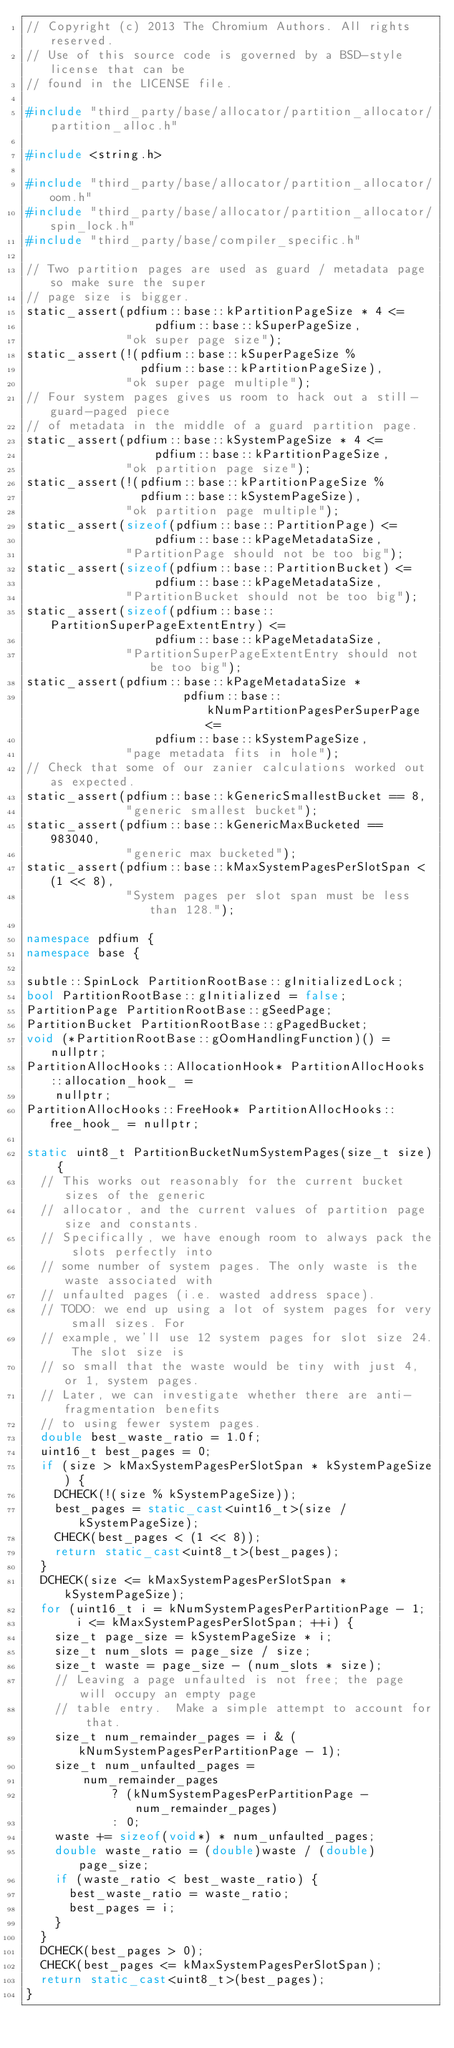<code> <loc_0><loc_0><loc_500><loc_500><_C++_>// Copyright (c) 2013 The Chromium Authors. All rights reserved.
// Use of this source code is governed by a BSD-style license that can be
// found in the LICENSE file.

#include "third_party/base/allocator/partition_allocator/partition_alloc.h"

#include <string.h>

#include "third_party/base/allocator/partition_allocator/oom.h"
#include "third_party/base/allocator/partition_allocator/spin_lock.h"
#include "third_party/base/compiler_specific.h"

// Two partition pages are used as guard / metadata page so make sure the super
// page size is bigger.
static_assert(pdfium::base::kPartitionPageSize * 4 <=
                  pdfium::base::kSuperPageSize,
              "ok super page size");
static_assert(!(pdfium::base::kSuperPageSize %
                pdfium::base::kPartitionPageSize),
              "ok super page multiple");
// Four system pages gives us room to hack out a still-guard-paged piece
// of metadata in the middle of a guard partition page.
static_assert(pdfium::base::kSystemPageSize * 4 <=
                  pdfium::base::kPartitionPageSize,
              "ok partition page size");
static_assert(!(pdfium::base::kPartitionPageSize %
                pdfium::base::kSystemPageSize),
              "ok partition page multiple");
static_assert(sizeof(pdfium::base::PartitionPage) <=
                  pdfium::base::kPageMetadataSize,
              "PartitionPage should not be too big");
static_assert(sizeof(pdfium::base::PartitionBucket) <=
                  pdfium::base::kPageMetadataSize,
              "PartitionBucket should not be too big");
static_assert(sizeof(pdfium::base::PartitionSuperPageExtentEntry) <=
                  pdfium::base::kPageMetadataSize,
              "PartitionSuperPageExtentEntry should not be too big");
static_assert(pdfium::base::kPageMetadataSize *
                      pdfium::base::kNumPartitionPagesPerSuperPage <=
                  pdfium::base::kSystemPageSize,
              "page metadata fits in hole");
// Check that some of our zanier calculations worked out as expected.
static_assert(pdfium::base::kGenericSmallestBucket == 8,
              "generic smallest bucket");
static_assert(pdfium::base::kGenericMaxBucketed == 983040,
              "generic max bucketed");
static_assert(pdfium::base::kMaxSystemPagesPerSlotSpan < (1 << 8),
              "System pages per slot span must be less than 128.");

namespace pdfium {
namespace base {

subtle::SpinLock PartitionRootBase::gInitializedLock;
bool PartitionRootBase::gInitialized = false;
PartitionPage PartitionRootBase::gSeedPage;
PartitionBucket PartitionRootBase::gPagedBucket;
void (*PartitionRootBase::gOomHandlingFunction)() = nullptr;
PartitionAllocHooks::AllocationHook* PartitionAllocHooks::allocation_hook_ =
    nullptr;
PartitionAllocHooks::FreeHook* PartitionAllocHooks::free_hook_ = nullptr;

static uint8_t PartitionBucketNumSystemPages(size_t size) {
  // This works out reasonably for the current bucket sizes of the generic
  // allocator, and the current values of partition page size and constants.
  // Specifically, we have enough room to always pack the slots perfectly into
  // some number of system pages. The only waste is the waste associated with
  // unfaulted pages (i.e. wasted address space).
  // TODO: we end up using a lot of system pages for very small sizes. For
  // example, we'll use 12 system pages for slot size 24. The slot size is
  // so small that the waste would be tiny with just 4, or 1, system pages.
  // Later, we can investigate whether there are anti-fragmentation benefits
  // to using fewer system pages.
  double best_waste_ratio = 1.0f;
  uint16_t best_pages = 0;
  if (size > kMaxSystemPagesPerSlotSpan * kSystemPageSize) {
    DCHECK(!(size % kSystemPageSize));
    best_pages = static_cast<uint16_t>(size / kSystemPageSize);
    CHECK(best_pages < (1 << 8));
    return static_cast<uint8_t>(best_pages);
  }
  DCHECK(size <= kMaxSystemPagesPerSlotSpan * kSystemPageSize);
  for (uint16_t i = kNumSystemPagesPerPartitionPage - 1;
       i <= kMaxSystemPagesPerSlotSpan; ++i) {
    size_t page_size = kSystemPageSize * i;
    size_t num_slots = page_size / size;
    size_t waste = page_size - (num_slots * size);
    // Leaving a page unfaulted is not free; the page will occupy an empty page
    // table entry.  Make a simple attempt to account for that.
    size_t num_remainder_pages = i & (kNumSystemPagesPerPartitionPage - 1);
    size_t num_unfaulted_pages =
        num_remainder_pages
            ? (kNumSystemPagesPerPartitionPage - num_remainder_pages)
            : 0;
    waste += sizeof(void*) * num_unfaulted_pages;
    double waste_ratio = (double)waste / (double)page_size;
    if (waste_ratio < best_waste_ratio) {
      best_waste_ratio = waste_ratio;
      best_pages = i;
    }
  }
  DCHECK(best_pages > 0);
  CHECK(best_pages <= kMaxSystemPagesPerSlotSpan);
  return static_cast<uint8_t>(best_pages);
}
</code> 